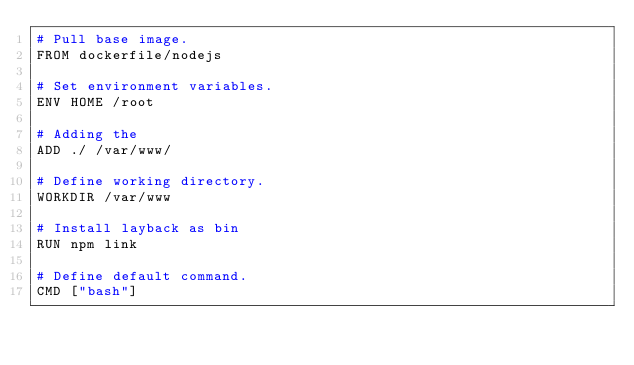<code> <loc_0><loc_0><loc_500><loc_500><_Dockerfile_># Pull base image.
FROM dockerfile/nodejs

# Set environment variables.
ENV HOME /root

# Adding the 
ADD ./ /var/www/

# Define working directory.
WORKDIR /var/www

# Install layback as bin
RUN npm link

# Define default command.
CMD ["bash"]</code> 